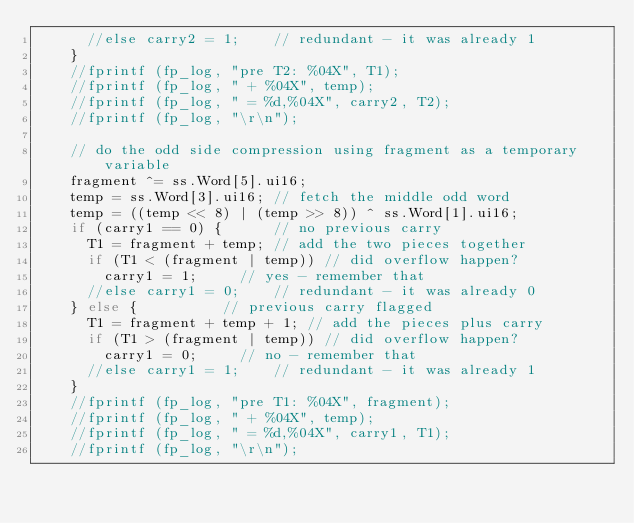<code> <loc_0><loc_0><loc_500><loc_500><_C++_>			//else carry2 = 1;		// redundant - it was already 1
		}
		//fprintf (fp_log, "pre T2: %04X", T1);
		//fprintf (fp_log, " + %04X", temp);
		//fprintf (fp_log, " = %d,%04X", carry2, T2);
		//fprintf (fp_log, "\r\n");

		// do the odd side compression using fragment as a temporary variable
		fragment ^= ss.Word[5].ui16;
		temp = ss.Word[3].ui16;	// fetch the middle odd word
		temp = ((temp << 8) | (temp >> 8)) ^ ss.Word[1].ui16;
		if (carry1 == 0) {			// no previous carry
			T1 = fragment + temp;	// add the two pieces together
			if (T1 < (fragment | temp))	// did overflow happen?
				carry1 = 1;			// yes - remember that
			//else carry1 = 0;		// redundant - it was already 0
		} else {					// previous carry flagged
			T1 = fragment + temp + 1;	// add the pieces plus carry
			if (T1 > (fragment | temp))	// did overflow happen?
				carry1 = 0;			// no - remember that
			//else carry1 = 1;		// redundant - it was already 1
		}
		//fprintf (fp_log, "pre T1: %04X", fragment);
		//fprintf (fp_log, " + %04X", temp);
		//fprintf (fp_log, " = %d,%04X", carry1, T1);
		//fprintf (fp_log, "\r\n");
</code> 